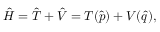Convert formula to latex. <formula><loc_0><loc_0><loc_500><loc_500>\hat { H } = \hat { T } + \hat { V } = T ( \hat { p } ) + V ( \hat { q } ) ,</formula> 